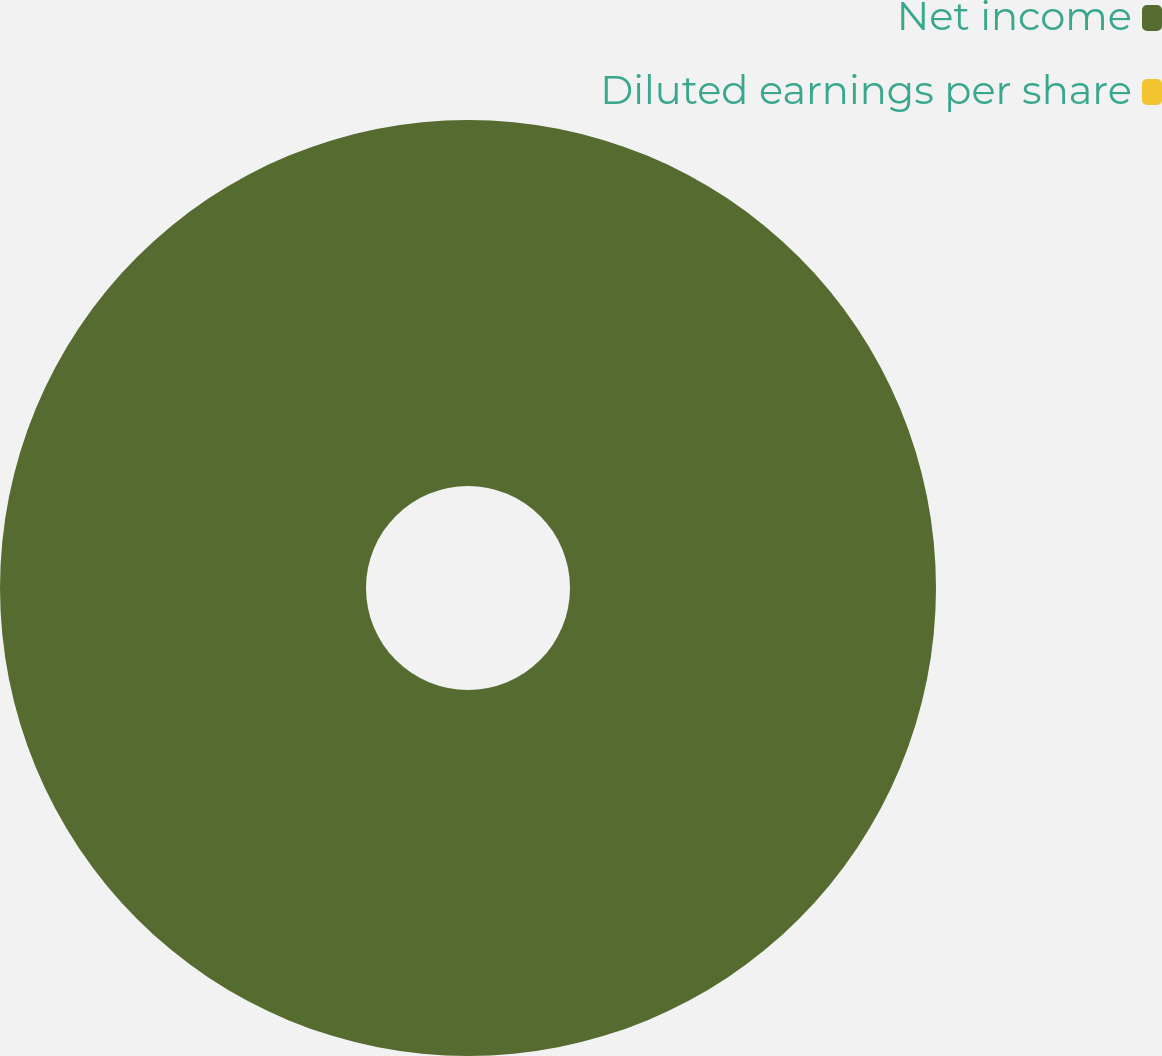Convert chart. <chart><loc_0><loc_0><loc_500><loc_500><pie_chart><fcel>Net income<fcel>Diluted earnings per share<nl><fcel>100.0%<fcel>0.0%<nl></chart> 